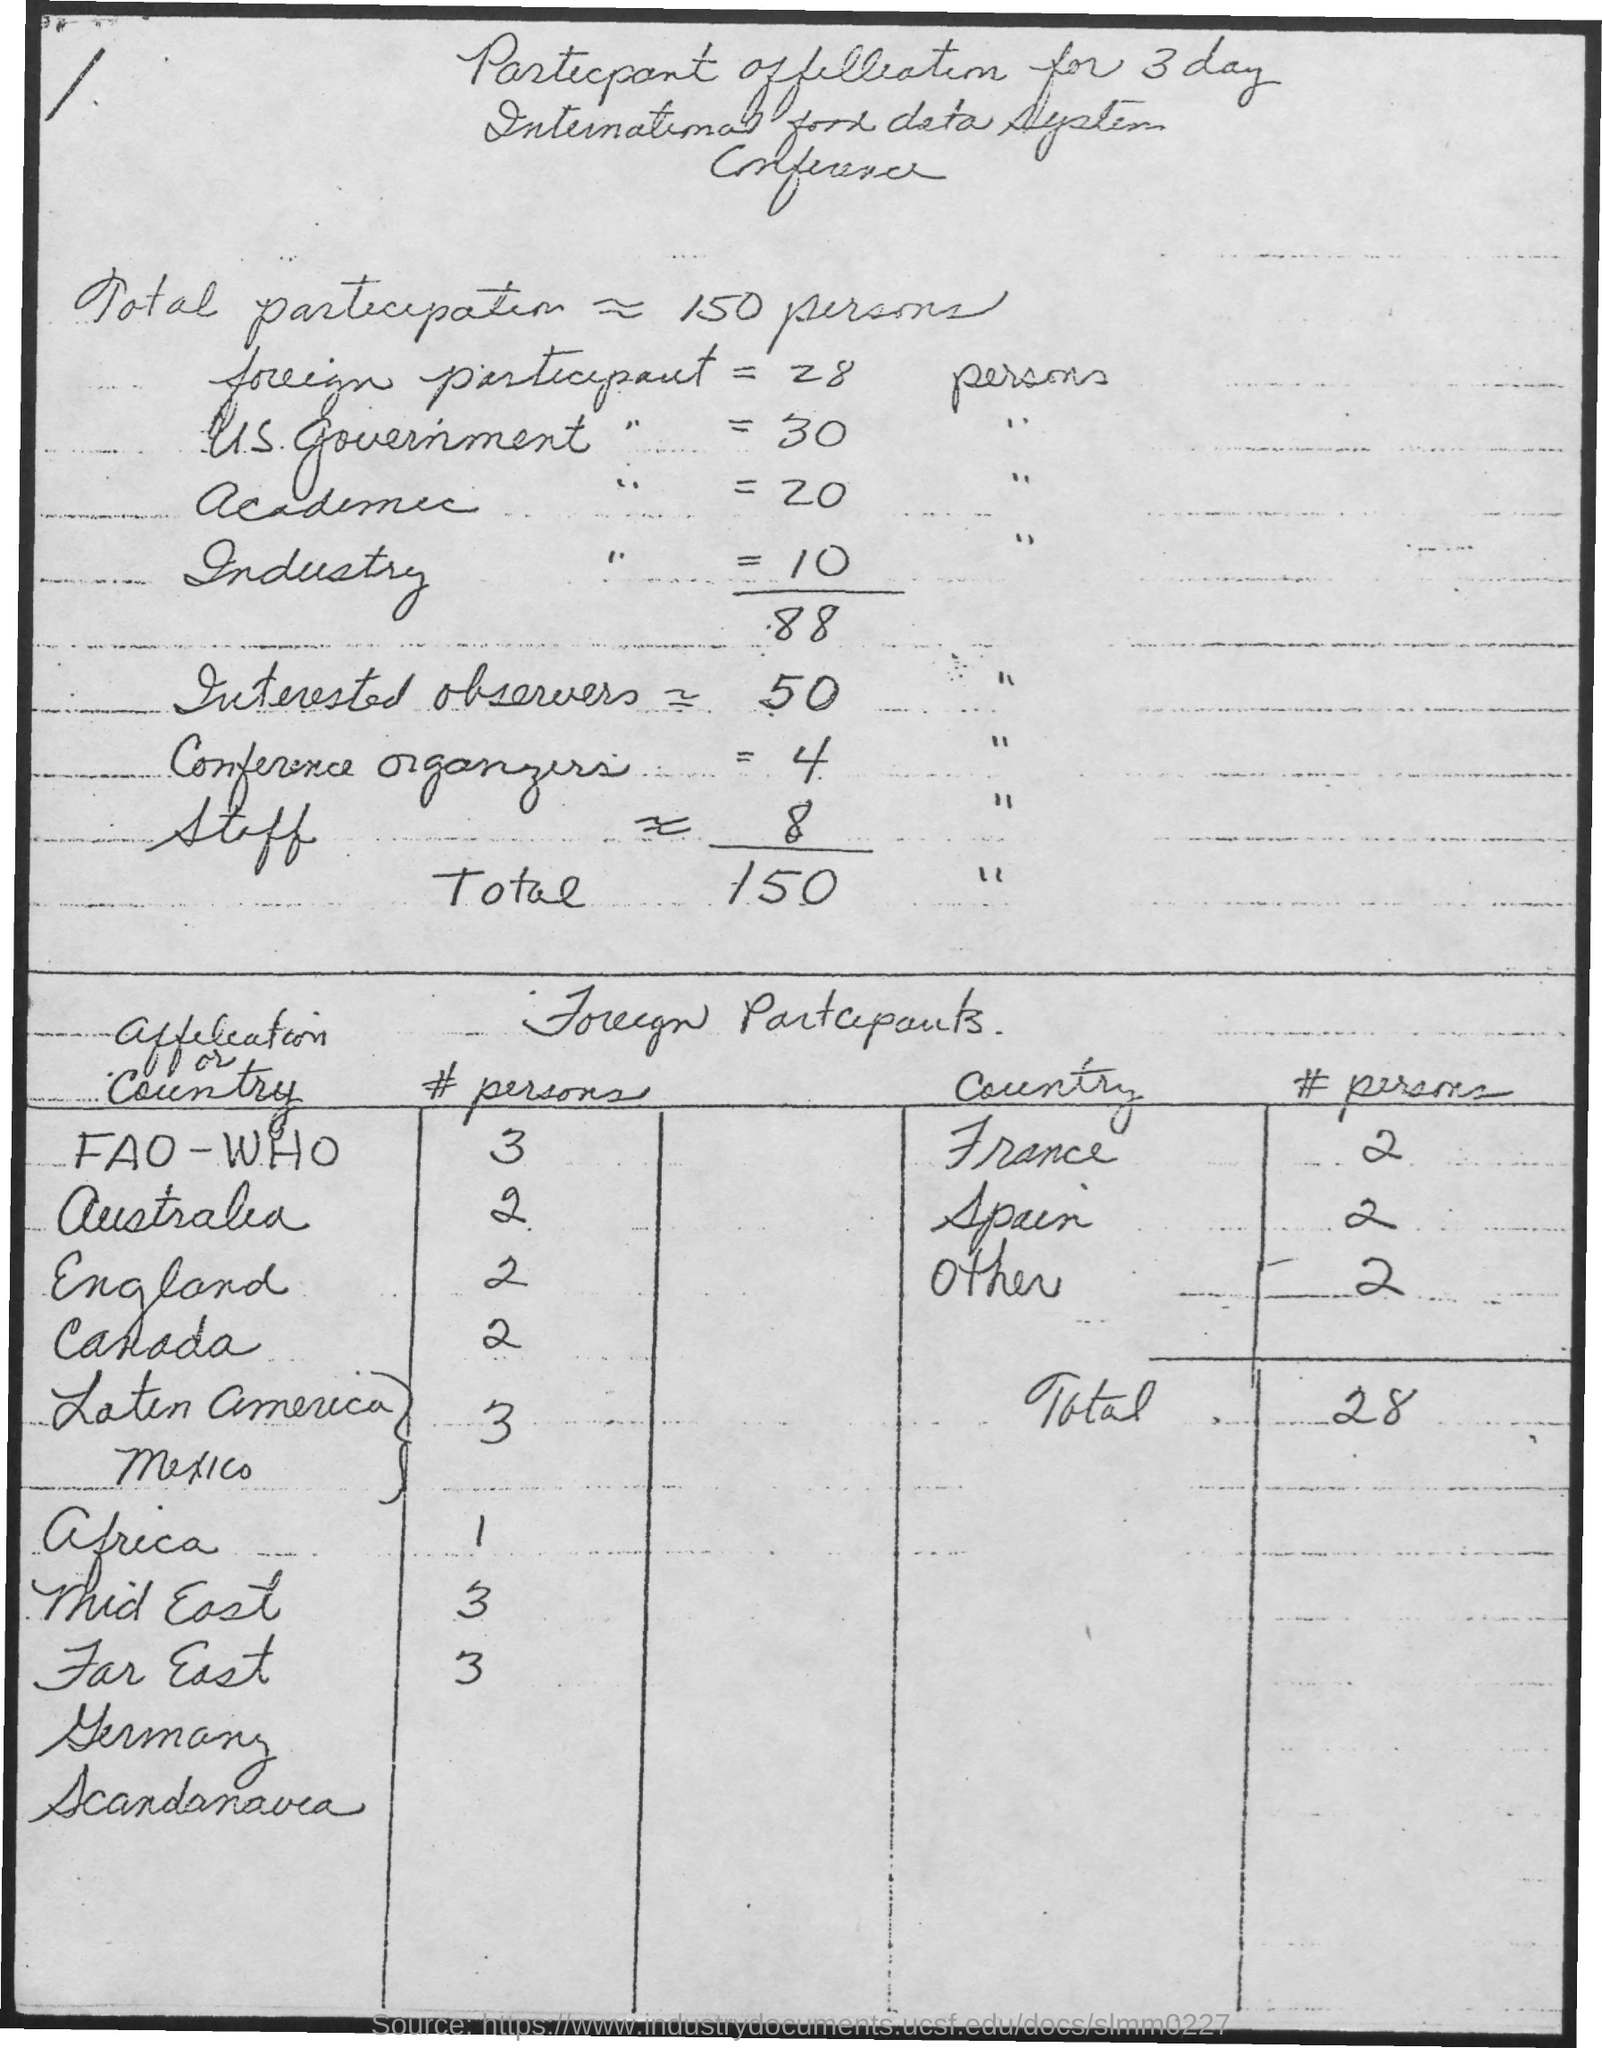What is the number of foreign participants?
Ensure brevity in your answer.  28. What is the number of total participants?
Offer a terse response. 150. What is the number of US. Government participants?
Make the answer very short. 30. What is the number of academic participants?
Provide a succinct answer. 20. What is the number of Industry participants?
Provide a short and direct response. 10. What is the number of interested observers?
Your answer should be very brief. 50 ". What is the number of conference organizers?
Your answer should be compact. 4 ". What is the number of staff?
Offer a very short reply. 8 ". What is the # persons from France?
Ensure brevity in your answer.  2. What is the # persons from Spain?
Your response must be concise. 2. 